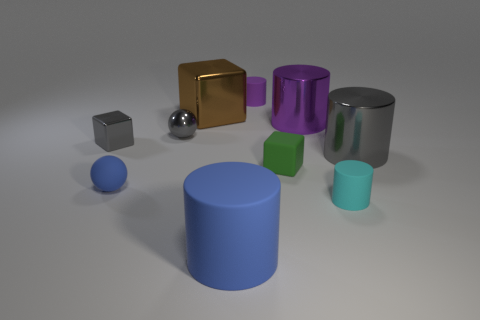What is the material of the tiny cube that is the same color as the shiny ball?
Make the answer very short. Metal. Do the small shiny sphere and the small block that is on the left side of the large brown block have the same color?
Ensure brevity in your answer.  Yes. Does the small matte thing that is behind the brown metallic thing have the same shape as the small green object?
Provide a succinct answer. No. How many other things are the same shape as the small purple matte object?
Ensure brevity in your answer.  4. How many things are tiny brown metallic balls or rubber objects that are in front of the tiny cyan matte thing?
Provide a succinct answer. 1. Is the number of shiny cylinders to the left of the gray shiny cylinder greater than the number of large blocks that are in front of the big blue matte thing?
Give a very brief answer. Yes. What is the shape of the tiny rubber thing that is behind the tiny cube that is on the left side of the small matte cylinder behind the gray shiny block?
Keep it short and to the point. Cylinder. There is a tiny rubber object right of the small green matte thing in front of the big brown thing; what shape is it?
Give a very brief answer. Cylinder. Is there a small ball that has the same material as the big blue thing?
Your answer should be very brief. Yes. There is a metal cube that is the same color as the metallic ball; what size is it?
Keep it short and to the point. Small. 